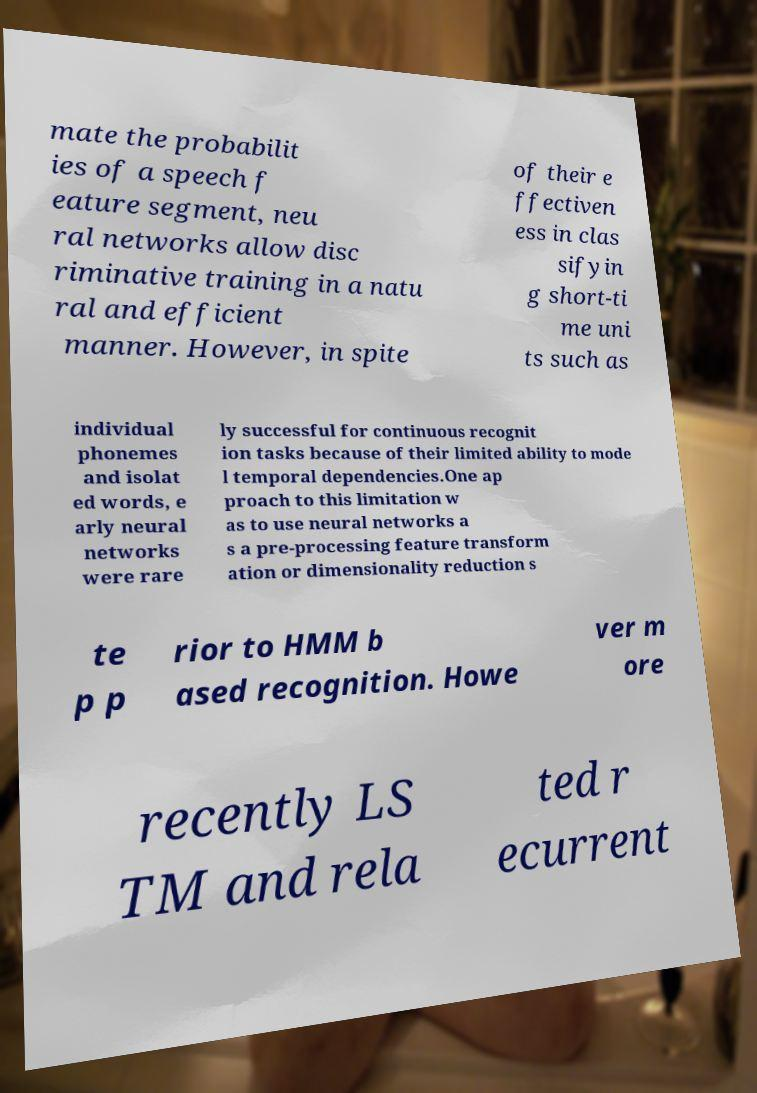Can you read and provide the text displayed in the image?This photo seems to have some interesting text. Can you extract and type it out for me? mate the probabilit ies of a speech f eature segment, neu ral networks allow disc riminative training in a natu ral and efficient manner. However, in spite of their e ffectiven ess in clas sifyin g short-ti me uni ts such as individual phonemes and isolat ed words, e arly neural networks were rare ly successful for continuous recognit ion tasks because of their limited ability to mode l temporal dependencies.One ap proach to this limitation w as to use neural networks a s a pre-processing feature transform ation or dimensionality reduction s te p p rior to HMM b ased recognition. Howe ver m ore recently LS TM and rela ted r ecurrent 